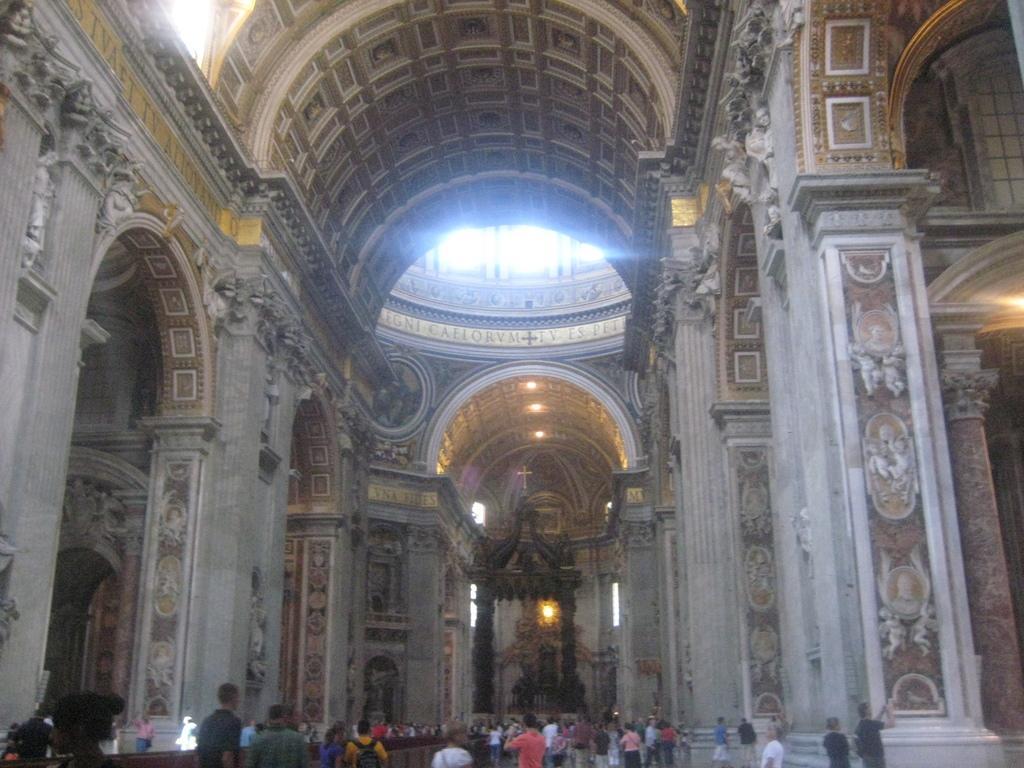In one or two sentences, can you explain what this image depicts? As we can see in the image there is a wall, few people here and there, lights, sculptures and there is a statue over here. 